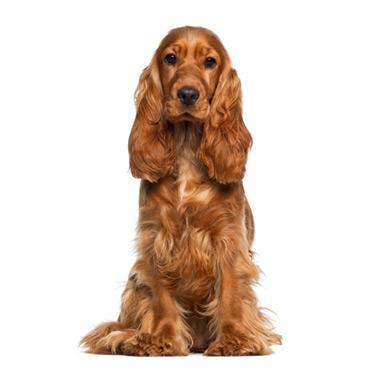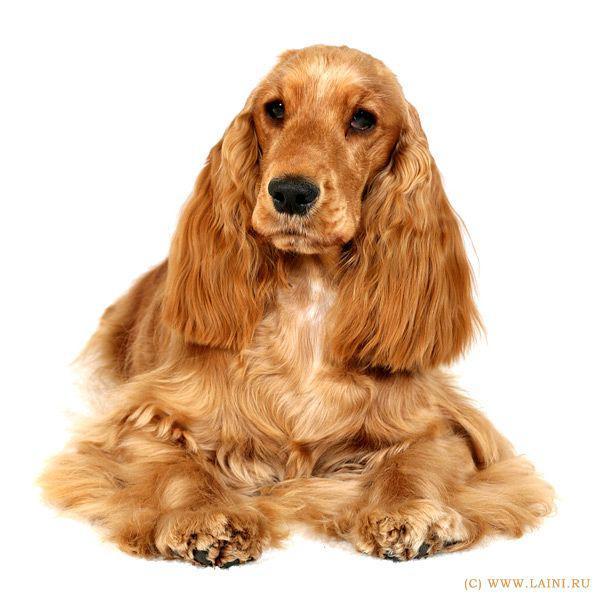The first image is the image on the left, the second image is the image on the right. Examine the images to the left and right. Is the description "There is one dog with its tongue out." accurate? Answer yes or no. No. The first image is the image on the left, the second image is the image on the right. Assess this claim about the two images: "A single dog tongue can be seen in the image on the left". Correct or not? Answer yes or no. No. 